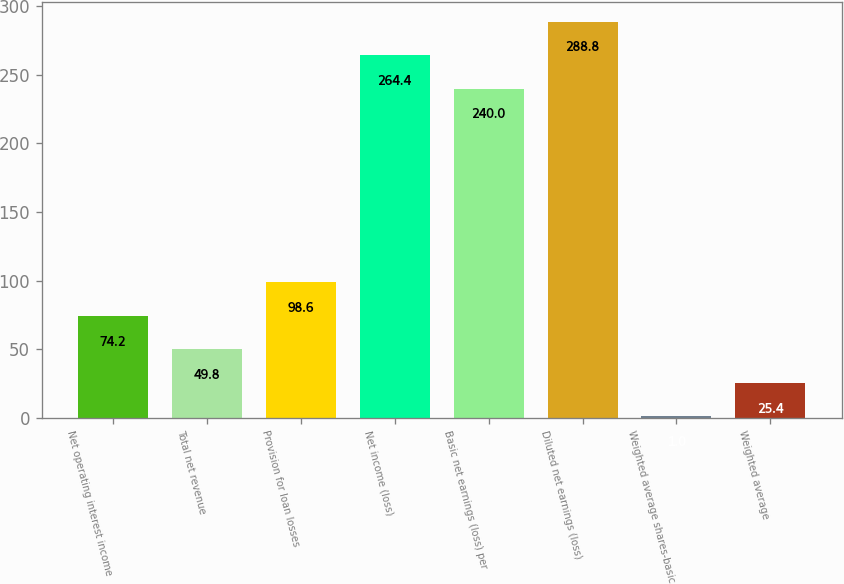Convert chart. <chart><loc_0><loc_0><loc_500><loc_500><bar_chart><fcel>Net operating interest income<fcel>Total net revenue<fcel>Provision for loan losses<fcel>Net income (loss)<fcel>Basic net earnings (loss) per<fcel>Diluted net earnings (loss)<fcel>Weighted average shares-basic<fcel>Weighted average<nl><fcel>74.2<fcel>49.8<fcel>98.6<fcel>264.4<fcel>240<fcel>288.8<fcel>1<fcel>25.4<nl></chart> 